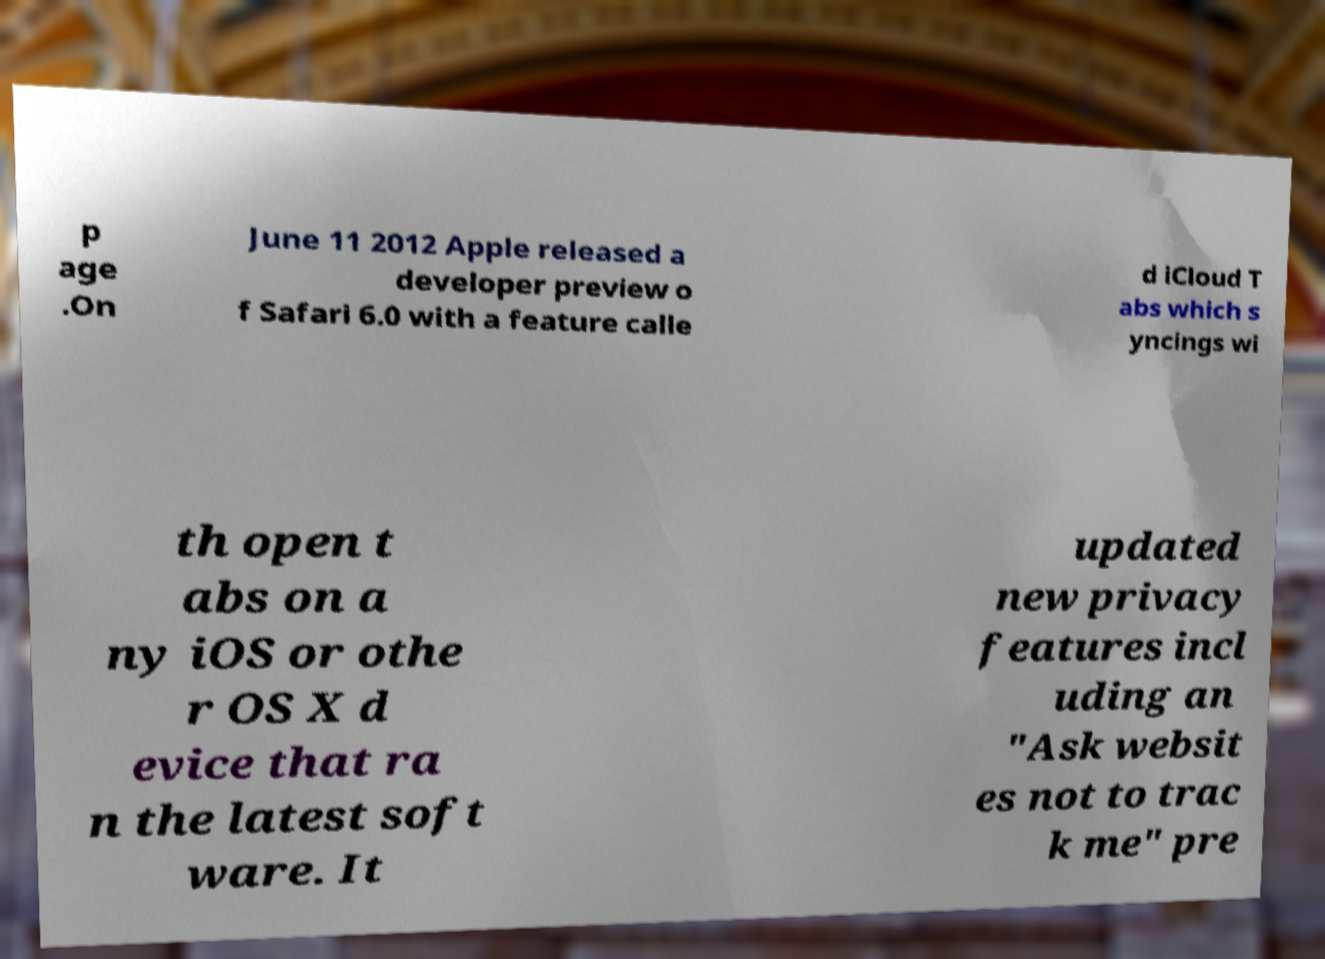Please identify and transcribe the text found in this image. p age .On June 11 2012 Apple released a developer preview o f Safari 6.0 with a feature calle d iCloud T abs which s yncings wi th open t abs on a ny iOS or othe r OS X d evice that ra n the latest soft ware. It updated new privacy features incl uding an "Ask websit es not to trac k me" pre 